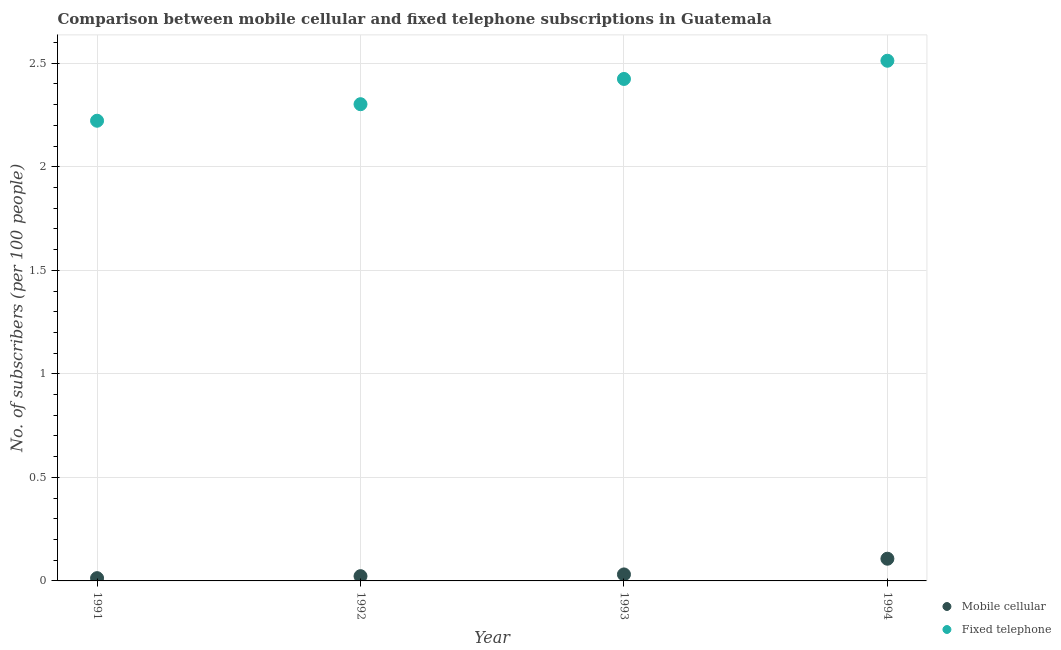Is the number of dotlines equal to the number of legend labels?
Your response must be concise. Yes. What is the number of mobile cellular subscribers in 1991?
Your answer should be very brief. 0.01. Across all years, what is the maximum number of mobile cellular subscribers?
Keep it short and to the point. 0.11. Across all years, what is the minimum number of fixed telephone subscribers?
Make the answer very short. 2.22. In which year was the number of fixed telephone subscribers maximum?
Ensure brevity in your answer.  1994. What is the total number of fixed telephone subscribers in the graph?
Offer a very short reply. 9.46. What is the difference between the number of fixed telephone subscribers in 1991 and that in 1992?
Your answer should be very brief. -0.08. What is the difference between the number of mobile cellular subscribers in 1994 and the number of fixed telephone subscribers in 1992?
Offer a terse response. -2.2. What is the average number of fixed telephone subscribers per year?
Provide a succinct answer. 2.37. In the year 1994, what is the difference between the number of fixed telephone subscribers and number of mobile cellular subscribers?
Keep it short and to the point. 2.4. In how many years, is the number of mobile cellular subscribers greater than 2.5?
Give a very brief answer. 0. What is the ratio of the number of fixed telephone subscribers in 1991 to that in 1992?
Your answer should be compact. 0.97. Is the number of mobile cellular subscribers in 1992 less than that in 1993?
Provide a short and direct response. Yes. Is the difference between the number of fixed telephone subscribers in 1992 and 1994 greater than the difference between the number of mobile cellular subscribers in 1992 and 1994?
Offer a very short reply. No. What is the difference between the highest and the second highest number of fixed telephone subscribers?
Your answer should be compact. 0.09. What is the difference between the highest and the lowest number of mobile cellular subscribers?
Give a very brief answer. 0.09. In how many years, is the number of mobile cellular subscribers greater than the average number of mobile cellular subscribers taken over all years?
Give a very brief answer. 1. Is the sum of the number of mobile cellular subscribers in 1991 and 1993 greater than the maximum number of fixed telephone subscribers across all years?
Keep it short and to the point. No. Does the number of mobile cellular subscribers monotonically increase over the years?
Ensure brevity in your answer.  Yes. Is the number of fixed telephone subscribers strictly less than the number of mobile cellular subscribers over the years?
Make the answer very short. No. Does the graph contain any zero values?
Your response must be concise. No. Where does the legend appear in the graph?
Make the answer very short. Bottom right. How many legend labels are there?
Your response must be concise. 2. How are the legend labels stacked?
Ensure brevity in your answer.  Vertical. What is the title of the graph?
Make the answer very short. Comparison between mobile cellular and fixed telephone subscriptions in Guatemala. Does "Non-resident workers" appear as one of the legend labels in the graph?
Ensure brevity in your answer.  No. What is the label or title of the X-axis?
Make the answer very short. Year. What is the label or title of the Y-axis?
Your answer should be very brief. No. of subscribers (per 100 people). What is the No. of subscribers (per 100 people) in Mobile cellular in 1991?
Keep it short and to the point. 0.01. What is the No. of subscribers (per 100 people) of Fixed telephone in 1991?
Your response must be concise. 2.22. What is the No. of subscribers (per 100 people) in Mobile cellular in 1992?
Keep it short and to the point. 0.02. What is the No. of subscribers (per 100 people) of Fixed telephone in 1992?
Keep it short and to the point. 2.3. What is the No. of subscribers (per 100 people) of Mobile cellular in 1993?
Your answer should be compact. 0.03. What is the No. of subscribers (per 100 people) in Fixed telephone in 1993?
Your response must be concise. 2.42. What is the No. of subscribers (per 100 people) in Mobile cellular in 1994?
Your response must be concise. 0.11. What is the No. of subscribers (per 100 people) in Fixed telephone in 1994?
Make the answer very short. 2.51. Across all years, what is the maximum No. of subscribers (per 100 people) in Mobile cellular?
Offer a terse response. 0.11. Across all years, what is the maximum No. of subscribers (per 100 people) in Fixed telephone?
Offer a terse response. 2.51. Across all years, what is the minimum No. of subscribers (per 100 people) in Mobile cellular?
Your answer should be compact. 0.01. Across all years, what is the minimum No. of subscribers (per 100 people) in Fixed telephone?
Your answer should be very brief. 2.22. What is the total No. of subscribers (per 100 people) of Mobile cellular in the graph?
Your answer should be compact. 0.17. What is the total No. of subscribers (per 100 people) of Fixed telephone in the graph?
Your response must be concise. 9.46. What is the difference between the No. of subscribers (per 100 people) of Mobile cellular in 1991 and that in 1992?
Provide a succinct answer. -0.01. What is the difference between the No. of subscribers (per 100 people) of Fixed telephone in 1991 and that in 1992?
Offer a very short reply. -0.08. What is the difference between the No. of subscribers (per 100 people) of Mobile cellular in 1991 and that in 1993?
Provide a short and direct response. -0.02. What is the difference between the No. of subscribers (per 100 people) of Fixed telephone in 1991 and that in 1993?
Your answer should be compact. -0.2. What is the difference between the No. of subscribers (per 100 people) of Mobile cellular in 1991 and that in 1994?
Offer a terse response. -0.09. What is the difference between the No. of subscribers (per 100 people) of Fixed telephone in 1991 and that in 1994?
Ensure brevity in your answer.  -0.29. What is the difference between the No. of subscribers (per 100 people) of Mobile cellular in 1992 and that in 1993?
Your response must be concise. -0.01. What is the difference between the No. of subscribers (per 100 people) in Fixed telephone in 1992 and that in 1993?
Your response must be concise. -0.12. What is the difference between the No. of subscribers (per 100 people) in Mobile cellular in 1992 and that in 1994?
Offer a terse response. -0.08. What is the difference between the No. of subscribers (per 100 people) of Fixed telephone in 1992 and that in 1994?
Make the answer very short. -0.21. What is the difference between the No. of subscribers (per 100 people) of Mobile cellular in 1993 and that in 1994?
Offer a terse response. -0.08. What is the difference between the No. of subscribers (per 100 people) of Fixed telephone in 1993 and that in 1994?
Your answer should be compact. -0.09. What is the difference between the No. of subscribers (per 100 people) of Mobile cellular in 1991 and the No. of subscribers (per 100 people) of Fixed telephone in 1992?
Your answer should be compact. -2.29. What is the difference between the No. of subscribers (per 100 people) in Mobile cellular in 1991 and the No. of subscribers (per 100 people) in Fixed telephone in 1993?
Your answer should be compact. -2.41. What is the difference between the No. of subscribers (per 100 people) of Mobile cellular in 1991 and the No. of subscribers (per 100 people) of Fixed telephone in 1994?
Your response must be concise. -2.5. What is the difference between the No. of subscribers (per 100 people) in Mobile cellular in 1992 and the No. of subscribers (per 100 people) in Fixed telephone in 1993?
Keep it short and to the point. -2.4. What is the difference between the No. of subscribers (per 100 people) of Mobile cellular in 1992 and the No. of subscribers (per 100 people) of Fixed telephone in 1994?
Give a very brief answer. -2.49. What is the difference between the No. of subscribers (per 100 people) of Mobile cellular in 1993 and the No. of subscribers (per 100 people) of Fixed telephone in 1994?
Keep it short and to the point. -2.48. What is the average No. of subscribers (per 100 people) in Mobile cellular per year?
Offer a terse response. 0.04. What is the average No. of subscribers (per 100 people) of Fixed telephone per year?
Your answer should be compact. 2.37. In the year 1991, what is the difference between the No. of subscribers (per 100 people) of Mobile cellular and No. of subscribers (per 100 people) of Fixed telephone?
Your answer should be very brief. -2.21. In the year 1992, what is the difference between the No. of subscribers (per 100 people) in Mobile cellular and No. of subscribers (per 100 people) in Fixed telephone?
Offer a very short reply. -2.28. In the year 1993, what is the difference between the No. of subscribers (per 100 people) in Mobile cellular and No. of subscribers (per 100 people) in Fixed telephone?
Your answer should be very brief. -2.39. In the year 1994, what is the difference between the No. of subscribers (per 100 people) of Mobile cellular and No. of subscribers (per 100 people) of Fixed telephone?
Your answer should be compact. -2.4. What is the ratio of the No. of subscribers (per 100 people) in Mobile cellular in 1991 to that in 1992?
Make the answer very short. 0.58. What is the ratio of the No. of subscribers (per 100 people) in Fixed telephone in 1991 to that in 1992?
Your response must be concise. 0.97. What is the ratio of the No. of subscribers (per 100 people) of Mobile cellular in 1991 to that in 1993?
Your answer should be compact. 0.43. What is the ratio of the No. of subscribers (per 100 people) in Fixed telephone in 1991 to that in 1993?
Make the answer very short. 0.92. What is the ratio of the No. of subscribers (per 100 people) in Mobile cellular in 1991 to that in 1994?
Provide a succinct answer. 0.13. What is the ratio of the No. of subscribers (per 100 people) of Fixed telephone in 1991 to that in 1994?
Provide a short and direct response. 0.88. What is the ratio of the No. of subscribers (per 100 people) in Mobile cellular in 1992 to that in 1993?
Your answer should be compact. 0.73. What is the ratio of the No. of subscribers (per 100 people) in Fixed telephone in 1992 to that in 1993?
Your response must be concise. 0.95. What is the ratio of the No. of subscribers (per 100 people) in Mobile cellular in 1992 to that in 1994?
Make the answer very short. 0.21. What is the ratio of the No. of subscribers (per 100 people) in Fixed telephone in 1992 to that in 1994?
Make the answer very short. 0.92. What is the ratio of the No. of subscribers (per 100 people) of Mobile cellular in 1993 to that in 1994?
Offer a terse response. 0.29. What is the difference between the highest and the second highest No. of subscribers (per 100 people) of Mobile cellular?
Your answer should be compact. 0.08. What is the difference between the highest and the second highest No. of subscribers (per 100 people) in Fixed telephone?
Give a very brief answer. 0.09. What is the difference between the highest and the lowest No. of subscribers (per 100 people) of Mobile cellular?
Provide a succinct answer. 0.09. What is the difference between the highest and the lowest No. of subscribers (per 100 people) in Fixed telephone?
Your answer should be very brief. 0.29. 